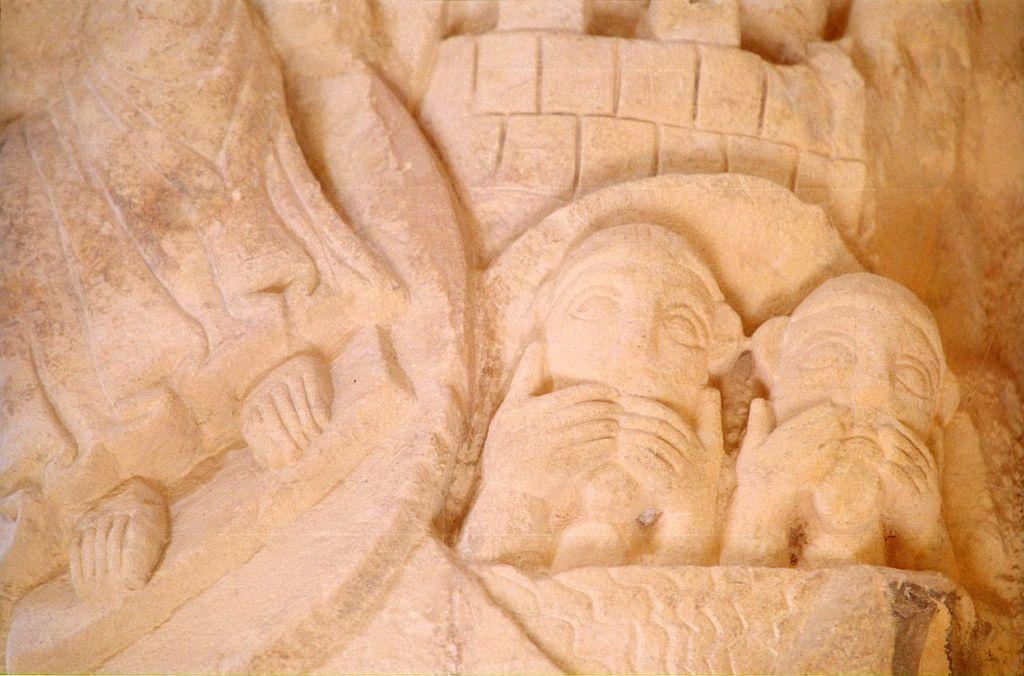Please provide a concise description of this image. We can see stone carving on the wall. 